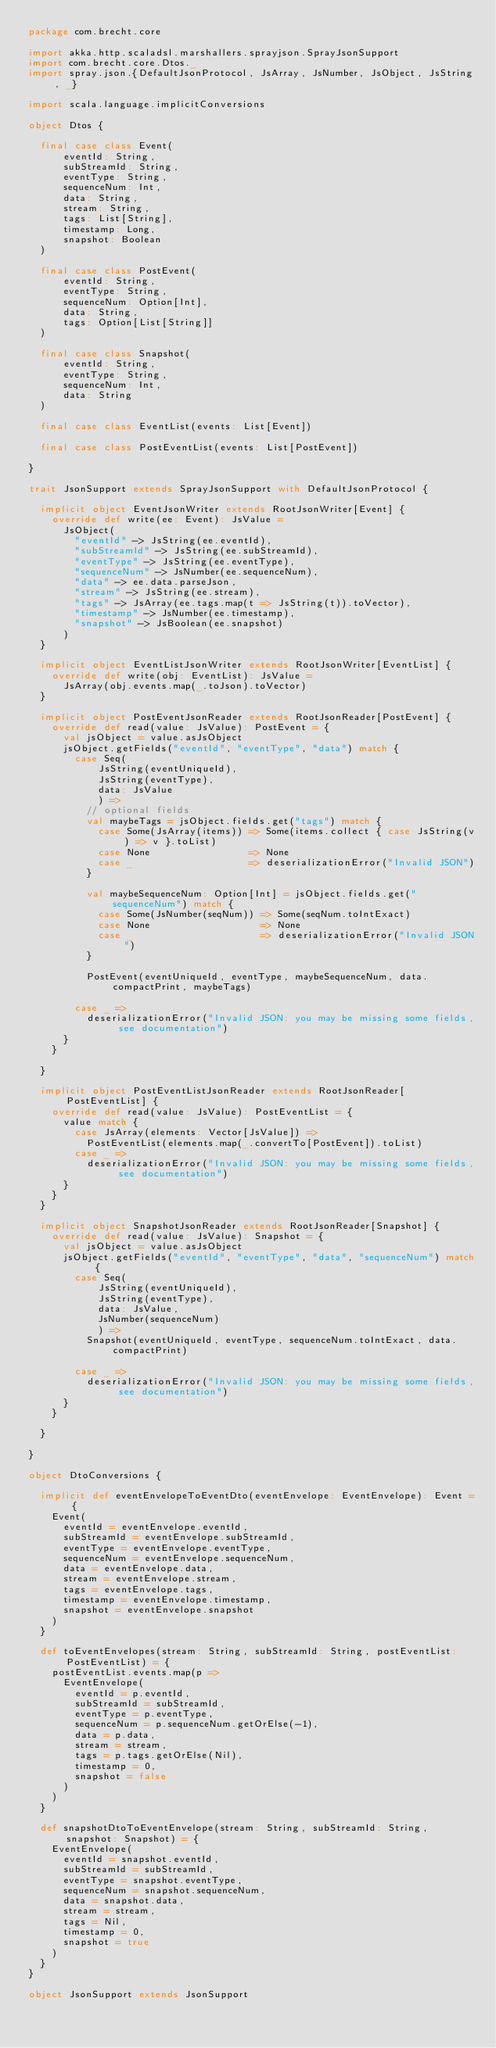<code> <loc_0><loc_0><loc_500><loc_500><_Scala_>package com.brecht.core

import akka.http.scaladsl.marshallers.sprayjson.SprayJsonSupport
import com.brecht.core.Dtos._
import spray.json.{DefaultJsonProtocol, JsArray, JsNumber, JsObject, JsString, _}

import scala.language.implicitConversions

object Dtos {

  final case class Event(
      eventId: String,
      subStreamId: String,
      eventType: String,
      sequenceNum: Int,
      data: String,
      stream: String,
      tags: List[String],
      timestamp: Long,
      snapshot: Boolean
  )

  final case class PostEvent(
      eventId: String,
      eventType: String,
      sequenceNum: Option[Int],
      data: String,
      tags: Option[List[String]]
  )

  final case class Snapshot(
      eventId: String,
      eventType: String,
      sequenceNum: Int,
      data: String
  )

  final case class EventList(events: List[Event])

  final case class PostEventList(events: List[PostEvent])

}

trait JsonSupport extends SprayJsonSupport with DefaultJsonProtocol {

  implicit object EventJsonWriter extends RootJsonWriter[Event] {
    override def write(ee: Event): JsValue =
      JsObject(
        "eventId" -> JsString(ee.eventId),
        "subStreamId" -> JsString(ee.subStreamId),
        "eventType" -> JsString(ee.eventType),
        "sequenceNum" -> JsNumber(ee.sequenceNum),
        "data" -> ee.data.parseJson,
        "stream" -> JsString(ee.stream),
        "tags" -> JsArray(ee.tags.map(t => JsString(t)).toVector),
        "timestamp" -> JsNumber(ee.timestamp),
        "snapshot" -> JsBoolean(ee.snapshot)
      )
  }

  implicit object EventListJsonWriter extends RootJsonWriter[EventList] {
    override def write(obj: EventList): JsValue =
      JsArray(obj.events.map(_.toJson).toVector)
  }

  implicit object PostEventJsonReader extends RootJsonReader[PostEvent] {
    override def read(value: JsValue): PostEvent = {
      val jsObject = value.asJsObject
      jsObject.getFields("eventId", "eventType", "data") match {
        case Seq(
            JsString(eventUniqueId),
            JsString(eventType),
            data: JsValue
            ) =>
          // optional fields
          val maybeTags = jsObject.fields.get("tags") match {
            case Some(JsArray(items)) => Some(items.collect { case JsString(v) => v }.toList)
            case None                 => None
            case _                    => deserializationError("Invalid JSON")
          }

          val maybeSequenceNum: Option[Int] = jsObject.fields.get("sequenceNum") match {
            case Some(JsNumber(seqNum)) => Some(seqNum.toIntExact)
            case None                   => None
            case _                      => deserializationError("Invalid JSON")
          }

          PostEvent(eventUniqueId, eventType, maybeSequenceNum, data.compactPrint, maybeTags)

        case _ =>
          deserializationError("Invalid JSON: you may be missing some fields, see documentation")
      }
    }

  }

  implicit object PostEventListJsonReader extends RootJsonReader[PostEventList] {
    override def read(value: JsValue): PostEventList = {
      value match {
        case JsArray(elements: Vector[JsValue]) =>
          PostEventList(elements.map(_.convertTo[PostEvent]).toList)
        case _ =>
          deserializationError("Invalid JSON: you may be missing some fields, see documentation")
      }
    }
  }

  implicit object SnapshotJsonReader extends RootJsonReader[Snapshot] {
    override def read(value: JsValue): Snapshot = {
      val jsObject = value.asJsObject
      jsObject.getFields("eventId", "eventType", "data", "sequenceNum") match {
        case Seq(
            JsString(eventUniqueId),
            JsString(eventType),
            data: JsValue,
            JsNumber(sequenceNum)
            ) =>
          Snapshot(eventUniqueId, eventType, sequenceNum.toIntExact, data.compactPrint)

        case _ =>
          deserializationError("Invalid JSON: you may be missing some fields, see documentation")
      }
    }

  }

}

object DtoConversions {

  implicit def eventEnvelopeToEventDto(eventEnvelope: EventEnvelope): Event = {
    Event(
      eventId = eventEnvelope.eventId,
      subStreamId = eventEnvelope.subStreamId,
      eventType = eventEnvelope.eventType,
      sequenceNum = eventEnvelope.sequenceNum,
      data = eventEnvelope.data,
      stream = eventEnvelope.stream,
      tags = eventEnvelope.tags,
      timestamp = eventEnvelope.timestamp,
      snapshot = eventEnvelope.snapshot
    )
  }

  def toEventEnvelopes(stream: String, subStreamId: String, postEventList: PostEventList) = {
    postEventList.events.map(p =>
      EventEnvelope(
        eventId = p.eventId,
        subStreamId = subStreamId,
        eventType = p.eventType,
        sequenceNum = p.sequenceNum.getOrElse(-1),
        data = p.data,
        stream = stream,
        tags = p.tags.getOrElse(Nil),
        timestamp = 0,
        snapshot = false
      )
    )
  }

  def snapshotDtoToEventEnvelope(stream: String, subStreamId: String, snapshot: Snapshot) = {
    EventEnvelope(
      eventId = snapshot.eventId,
      subStreamId = subStreamId,
      eventType = snapshot.eventType,
      sequenceNum = snapshot.sequenceNum,
      data = snapshot.data,
      stream = stream,
      tags = Nil,
      timestamp = 0,
      snapshot = true
    )
  }
}

object JsonSupport extends JsonSupport
</code> 